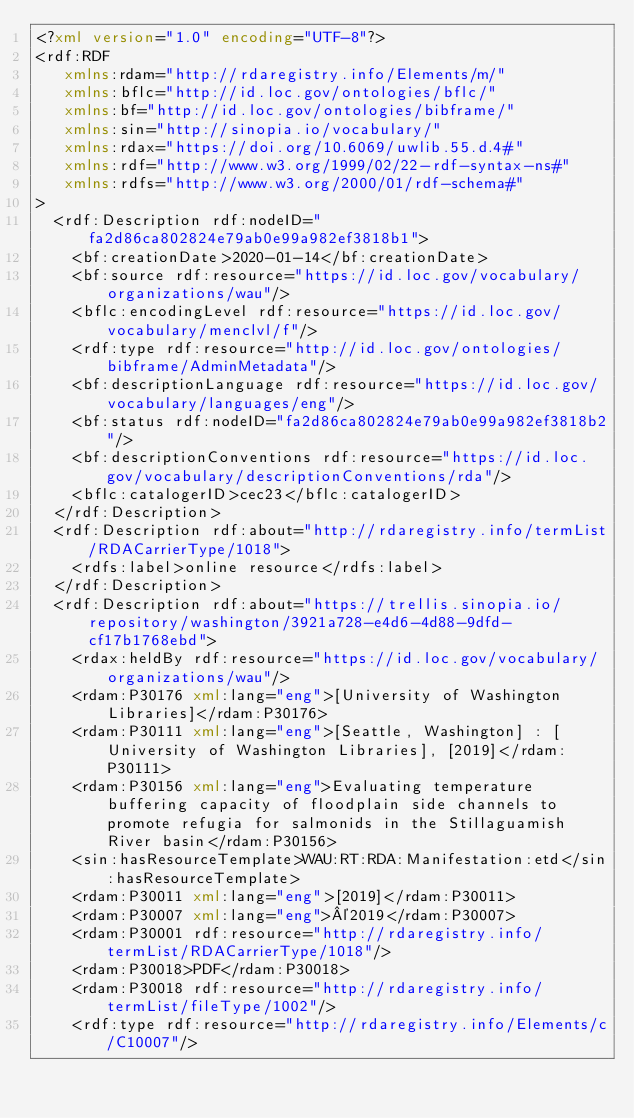Convert code to text. <code><loc_0><loc_0><loc_500><loc_500><_XML_><?xml version="1.0" encoding="UTF-8"?>
<rdf:RDF
   xmlns:rdam="http://rdaregistry.info/Elements/m/"
   xmlns:bflc="http://id.loc.gov/ontologies/bflc/"
   xmlns:bf="http://id.loc.gov/ontologies/bibframe/"
   xmlns:sin="http://sinopia.io/vocabulary/"
   xmlns:rdax="https://doi.org/10.6069/uwlib.55.d.4#"
   xmlns:rdf="http://www.w3.org/1999/02/22-rdf-syntax-ns#"
   xmlns:rdfs="http://www.w3.org/2000/01/rdf-schema#"
>
  <rdf:Description rdf:nodeID="fa2d86ca802824e79ab0e99a982ef3818b1">
    <bf:creationDate>2020-01-14</bf:creationDate>
    <bf:source rdf:resource="https://id.loc.gov/vocabulary/organizations/wau"/>
    <bflc:encodingLevel rdf:resource="https://id.loc.gov/vocabulary/menclvl/f"/>
    <rdf:type rdf:resource="http://id.loc.gov/ontologies/bibframe/AdminMetadata"/>
    <bf:descriptionLanguage rdf:resource="https://id.loc.gov/vocabulary/languages/eng"/>
    <bf:status rdf:nodeID="fa2d86ca802824e79ab0e99a982ef3818b2"/>
    <bf:descriptionConventions rdf:resource="https://id.loc.gov/vocabulary/descriptionConventions/rda"/>
    <bflc:catalogerID>cec23</bflc:catalogerID>
  </rdf:Description>
  <rdf:Description rdf:about="http://rdaregistry.info/termList/RDACarrierType/1018">
    <rdfs:label>online resource</rdfs:label>
  </rdf:Description>
  <rdf:Description rdf:about="https://trellis.sinopia.io/repository/washington/3921a728-e4d6-4d88-9dfd-cf17b1768ebd">
    <rdax:heldBy rdf:resource="https://id.loc.gov/vocabulary/organizations/wau"/>
    <rdam:P30176 xml:lang="eng">[University of Washington Libraries]</rdam:P30176>
    <rdam:P30111 xml:lang="eng">[Seattle, Washington] : [University of Washington Libraries], [2019]</rdam:P30111>
    <rdam:P30156 xml:lang="eng">Evaluating temperature buffering capacity of floodplain side channels to promote refugia for salmonids in the Stillaguamish River basin</rdam:P30156>
    <sin:hasResourceTemplate>WAU:RT:RDA:Manifestation:etd</sin:hasResourceTemplate>
    <rdam:P30011 xml:lang="eng">[2019]</rdam:P30011>
    <rdam:P30007 xml:lang="eng">©2019</rdam:P30007>
    <rdam:P30001 rdf:resource="http://rdaregistry.info/termList/RDACarrierType/1018"/>
    <rdam:P30018>PDF</rdam:P30018>
    <rdam:P30018 rdf:resource="http://rdaregistry.info/termList/fileType/1002"/>
    <rdf:type rdf:resource="http://rdaregistry.info/Elements/c/C10007"/></code> 